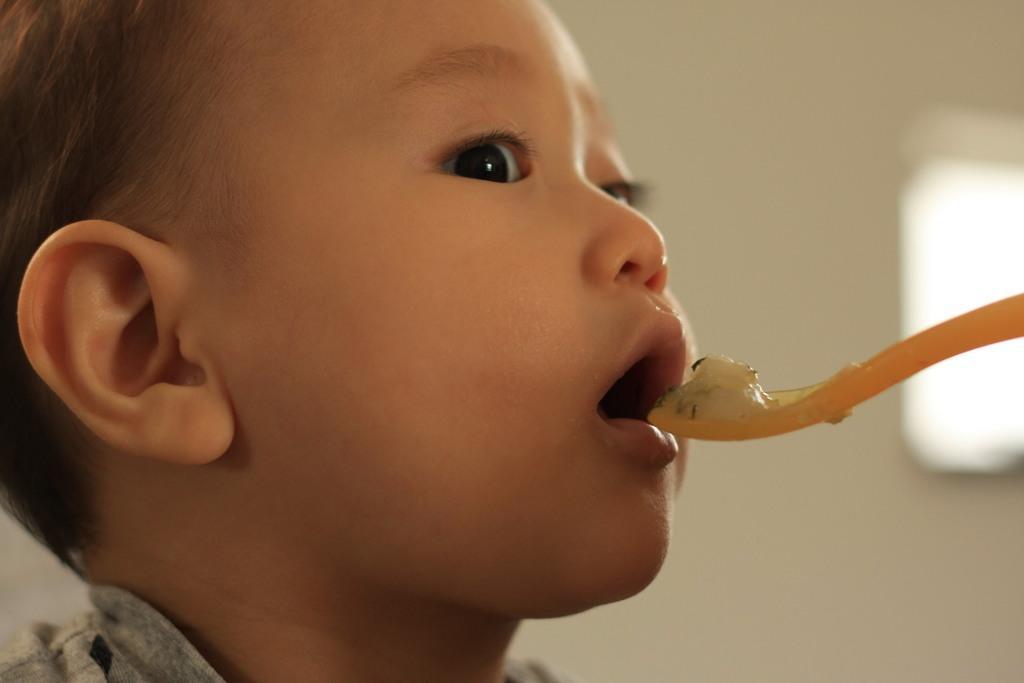In one or two sentences, can you explain what this image depicts? In this image I see a child's face and I see the yellow color spoon on which there is food and I see that it is blurred in the background. 